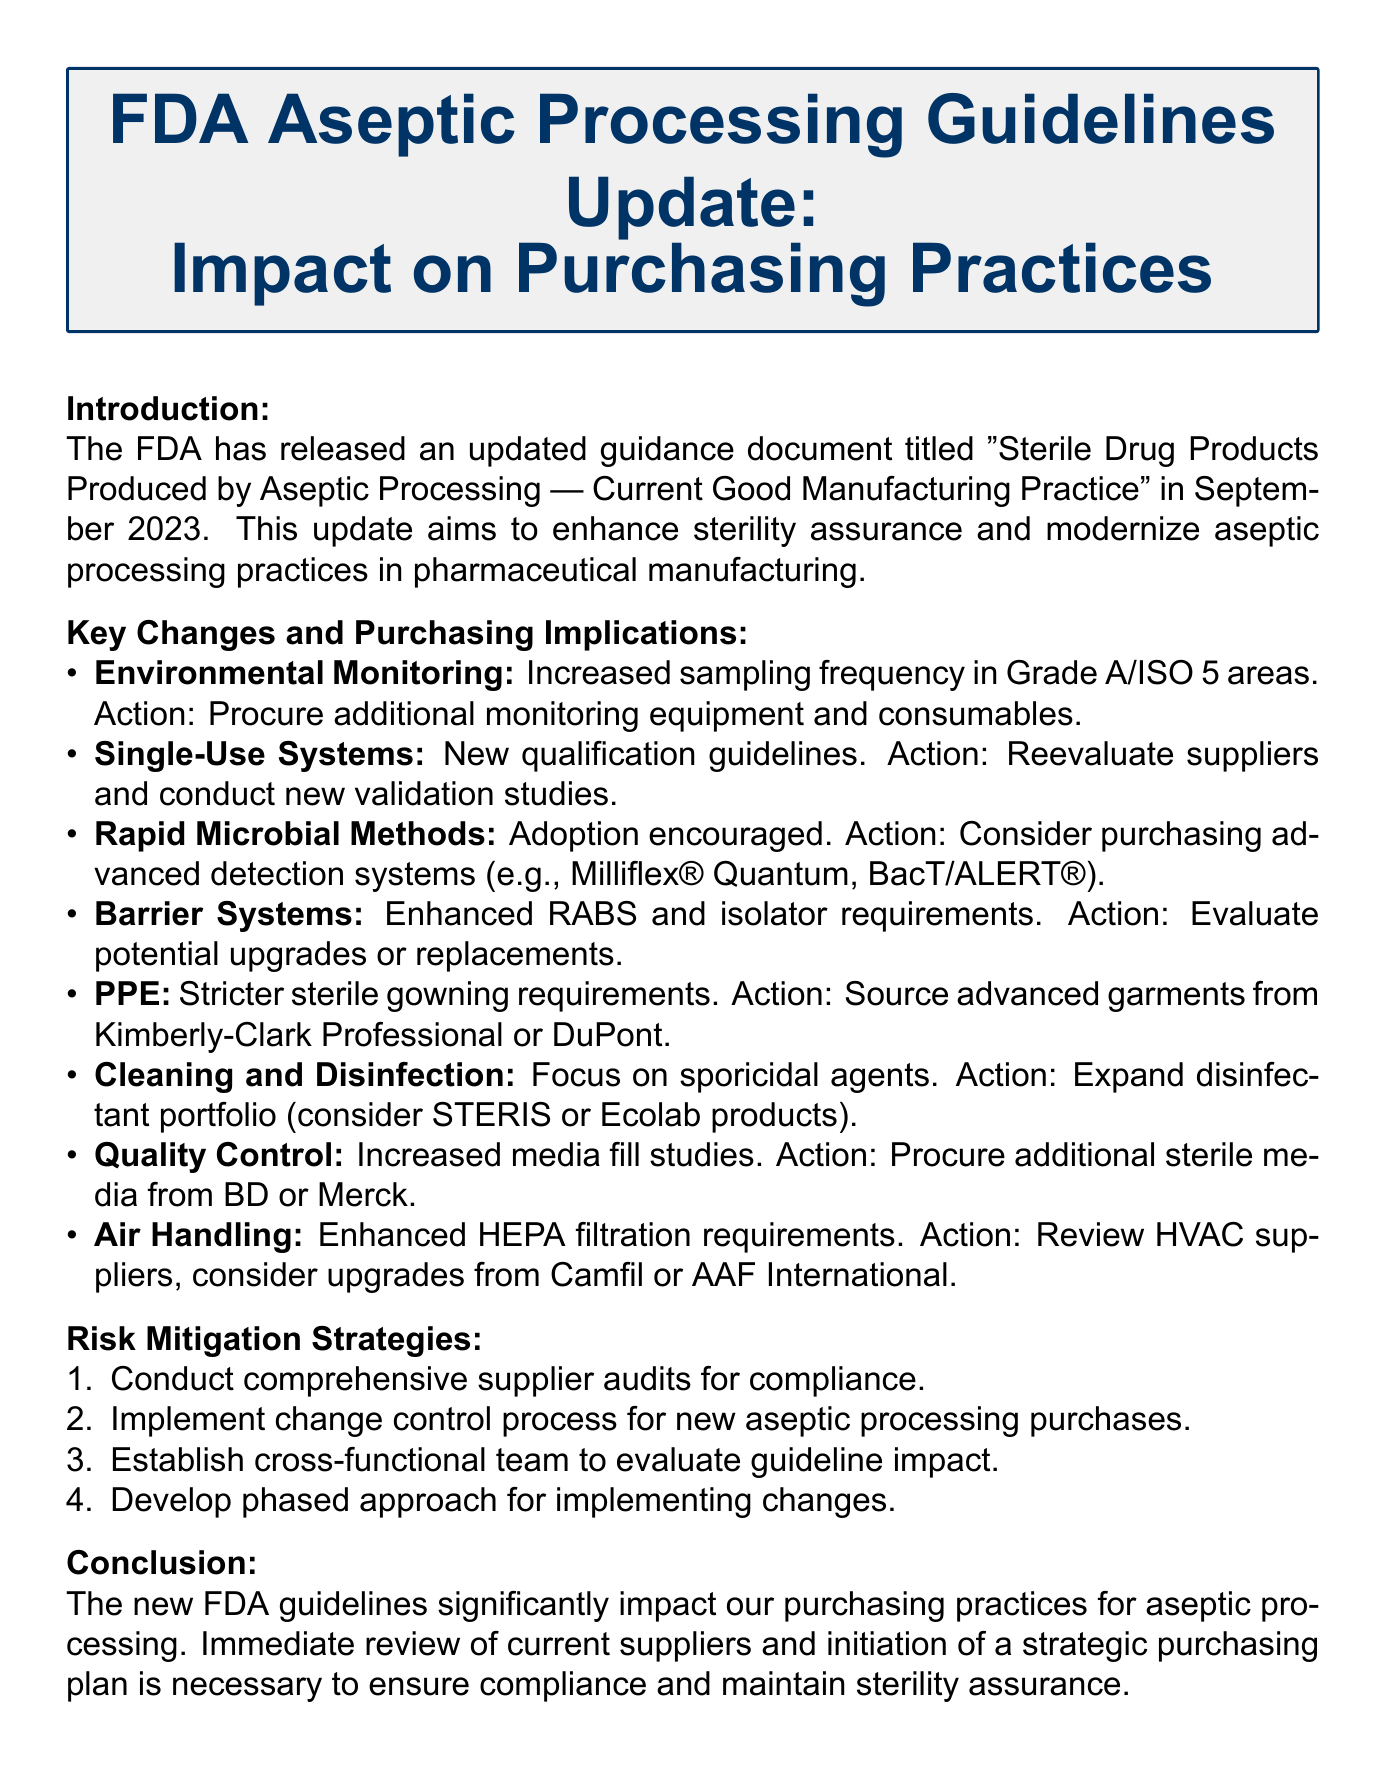what is the title of the guidance document? The title of the guidance document is "Sterile Drug Products Produced by Aseptic Processing — Current Good Manufacturing Practice".
Answer: "Sterile Drug Products Produced by Aseptic Processing — Current Good Manufacturing Practice" what is the release date of the updated guidelines? The release date of the updated guidelines is indicated in the introduction section of the document.
Answer: September 2023 what is one of the key changes related to Environmental Monitoring? The key change related to Environmental Monitoring includes increased frequency of sampling in certain areas.
Answer: Increased frequency of viable air and surface sampling in Grade A/ISO 5 areas which company is suggested for sourcing advanced sterile garments? The document suggests specific suppliers for sourcing advanced sterile garments.
Answer: Kimberly-Clark Professional or DuPont how many risk mitigation strategies are listed in the document? The number of risk mitigation strategies can be found in the corresponding section of the document.
Answer: Four what is one potential purchasing implication for Air Handling? The document highlights implications for different purchasing categories, including Air Handling.
Answer: Review current HVAC suppliers and consider upgrades from companies like Camfil or AAF International which two companies are mentioned for evaluating disinfectants? The document proposes specific companies to evaluate the disinfectants used in cleaning and disinfecting processes.
Answer: STERIS or Ecolab what is the main purpose of the updated FDA guidance? The purpose of the updated FDA guidance is summarized in the introduction.
Answer: To enhance sterility assurance and modernize aseptic processing practices in pharmaceutical manufacturing 